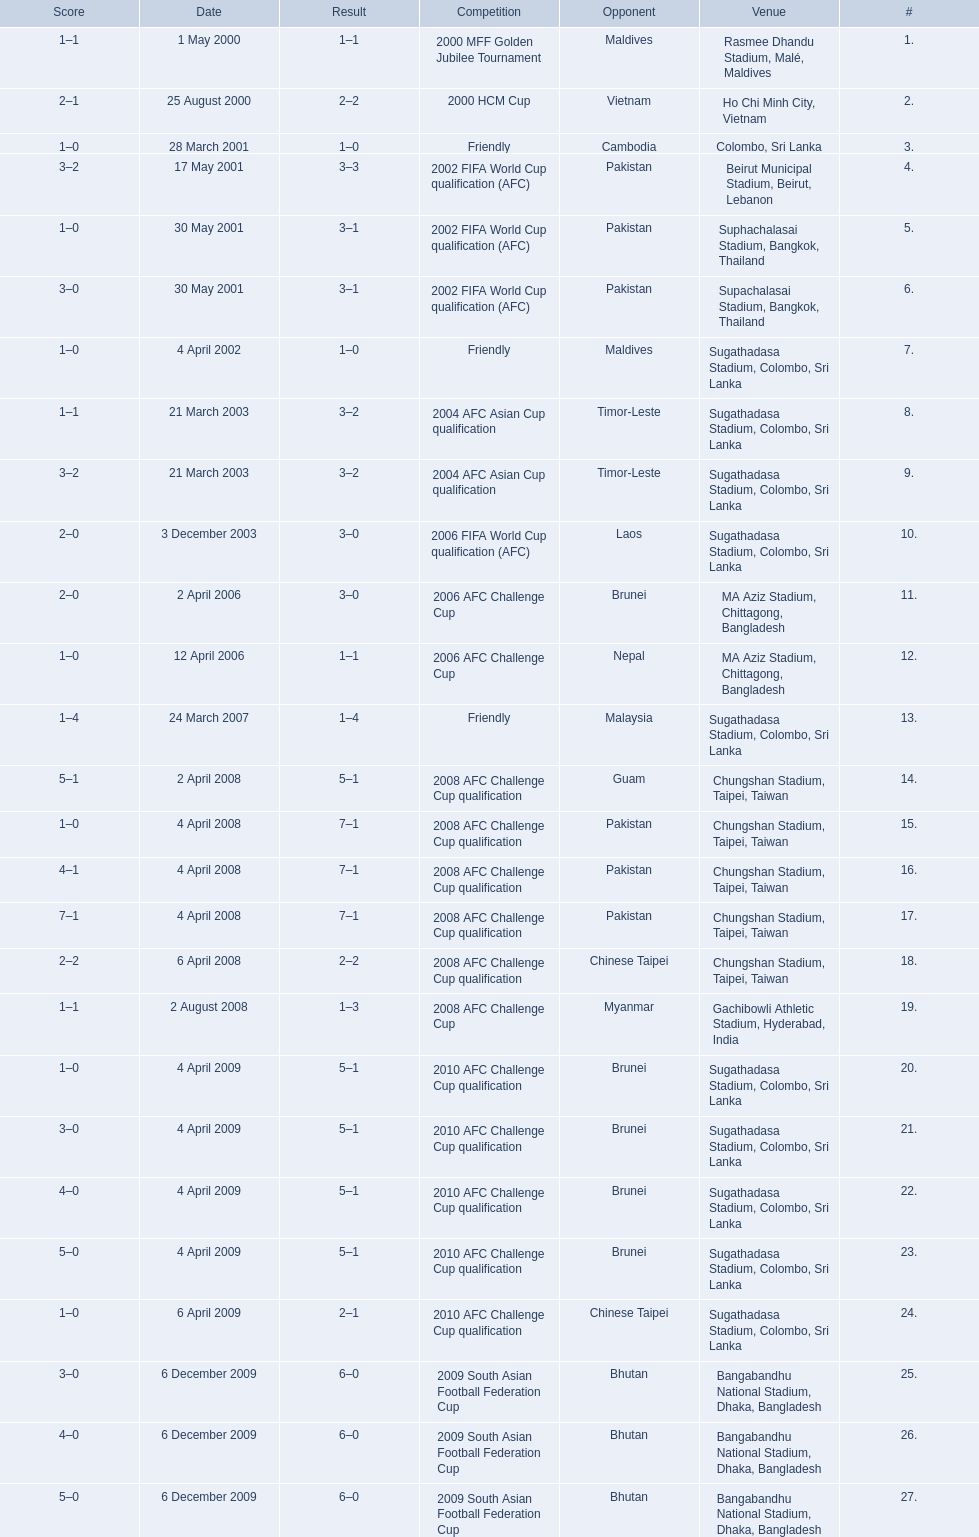What venues are listed? Rasmee Dhandu Stadium, Malé, Maldives, Ho Chi Minh City, Vietnam, Colombo, Sri Lanka, Beirut Municipal Stadium, Beirut, Lebanon, Suphachalasai Stadium, Bangkok, Thailand, MA Aziz Stadium, Chittagong, Bangladesh, Sugathadasa Stadium, Colombo, Sri Lanka, Chungshan Stadium, Taipei, Taiwan, Gachibowli Athletic Stadium, Hyderabad, India, Sugathadasa Stadium, Colombo, Sri Lanka, Bangabandhu National Stadium, Dhaka, Bangladesh. Which is top listed? Rasmee Dhandu Stadium, Malé, Maldives. 